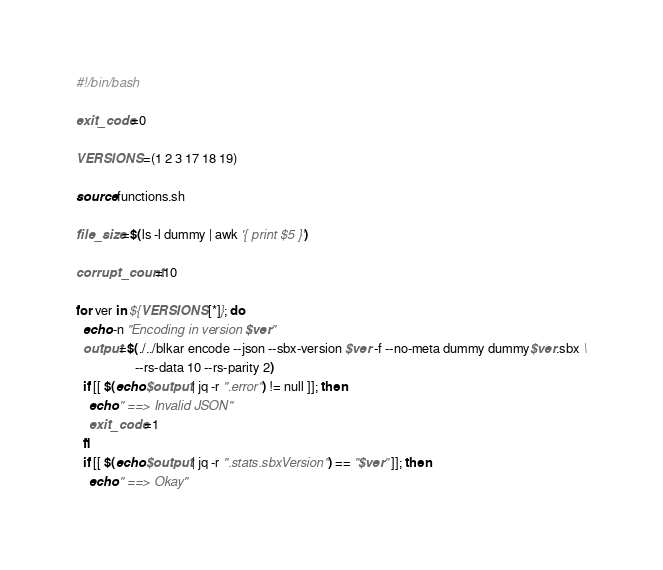<code> <loc_0><loc_0><loc_500><loc_500><_Bash_>#!/bin/bash

exit_code=0

VERSIONS=(1 2 3 17 18 19)

source functions.sh

file_size=$(ls -l dummy | awk '{ print $5 }')

corrupt_count=10

for ver in ${VERSIONS[*]}; do
  echo -n "Encoding in version $ver"
  output=$(./../blkar encode --json --sbx-version $ver -f --no-meta dummy dummy$ver.sbx \
                  --rs-data 10 --rs-parity 2)
  if [[ $(echo $output | jq -r ".error") != null ]]; then
    echo " ==> Invalid JSON"
    exit_code=1
  fi
  if [[ $(echo $output | jq -r ".stats.sbxVersion") == "$ver" ]]; then
    echo " ==> Okay"</code> 